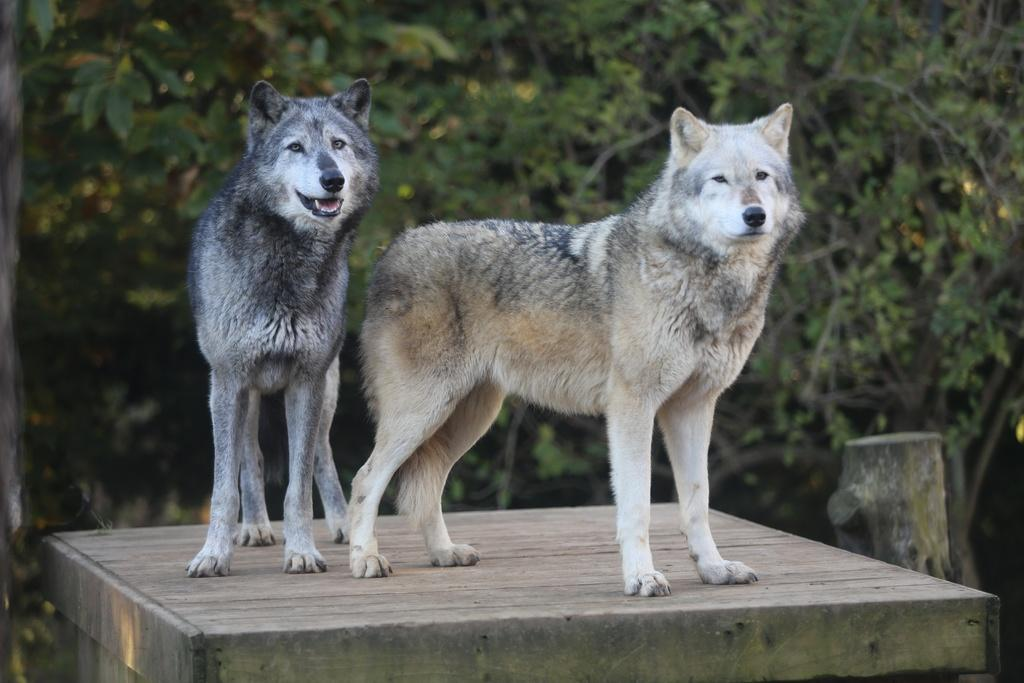How many dogs are in the image? There are two dogs in the image. What are the colors of the dogs? One dog is brown in color, and the other dog is black in color. What surface are the dogs on? The dogs are on a wooden surface. What can be seen in the background of the image? There are trees in the background of the image. Where is the uncle in the image? There is no uncle present in the image; it features two dogs on a wooden surface with trees in the background. What type of chain can be seen connecting the bikes in the image? There are no bikes or chains present in the image. 